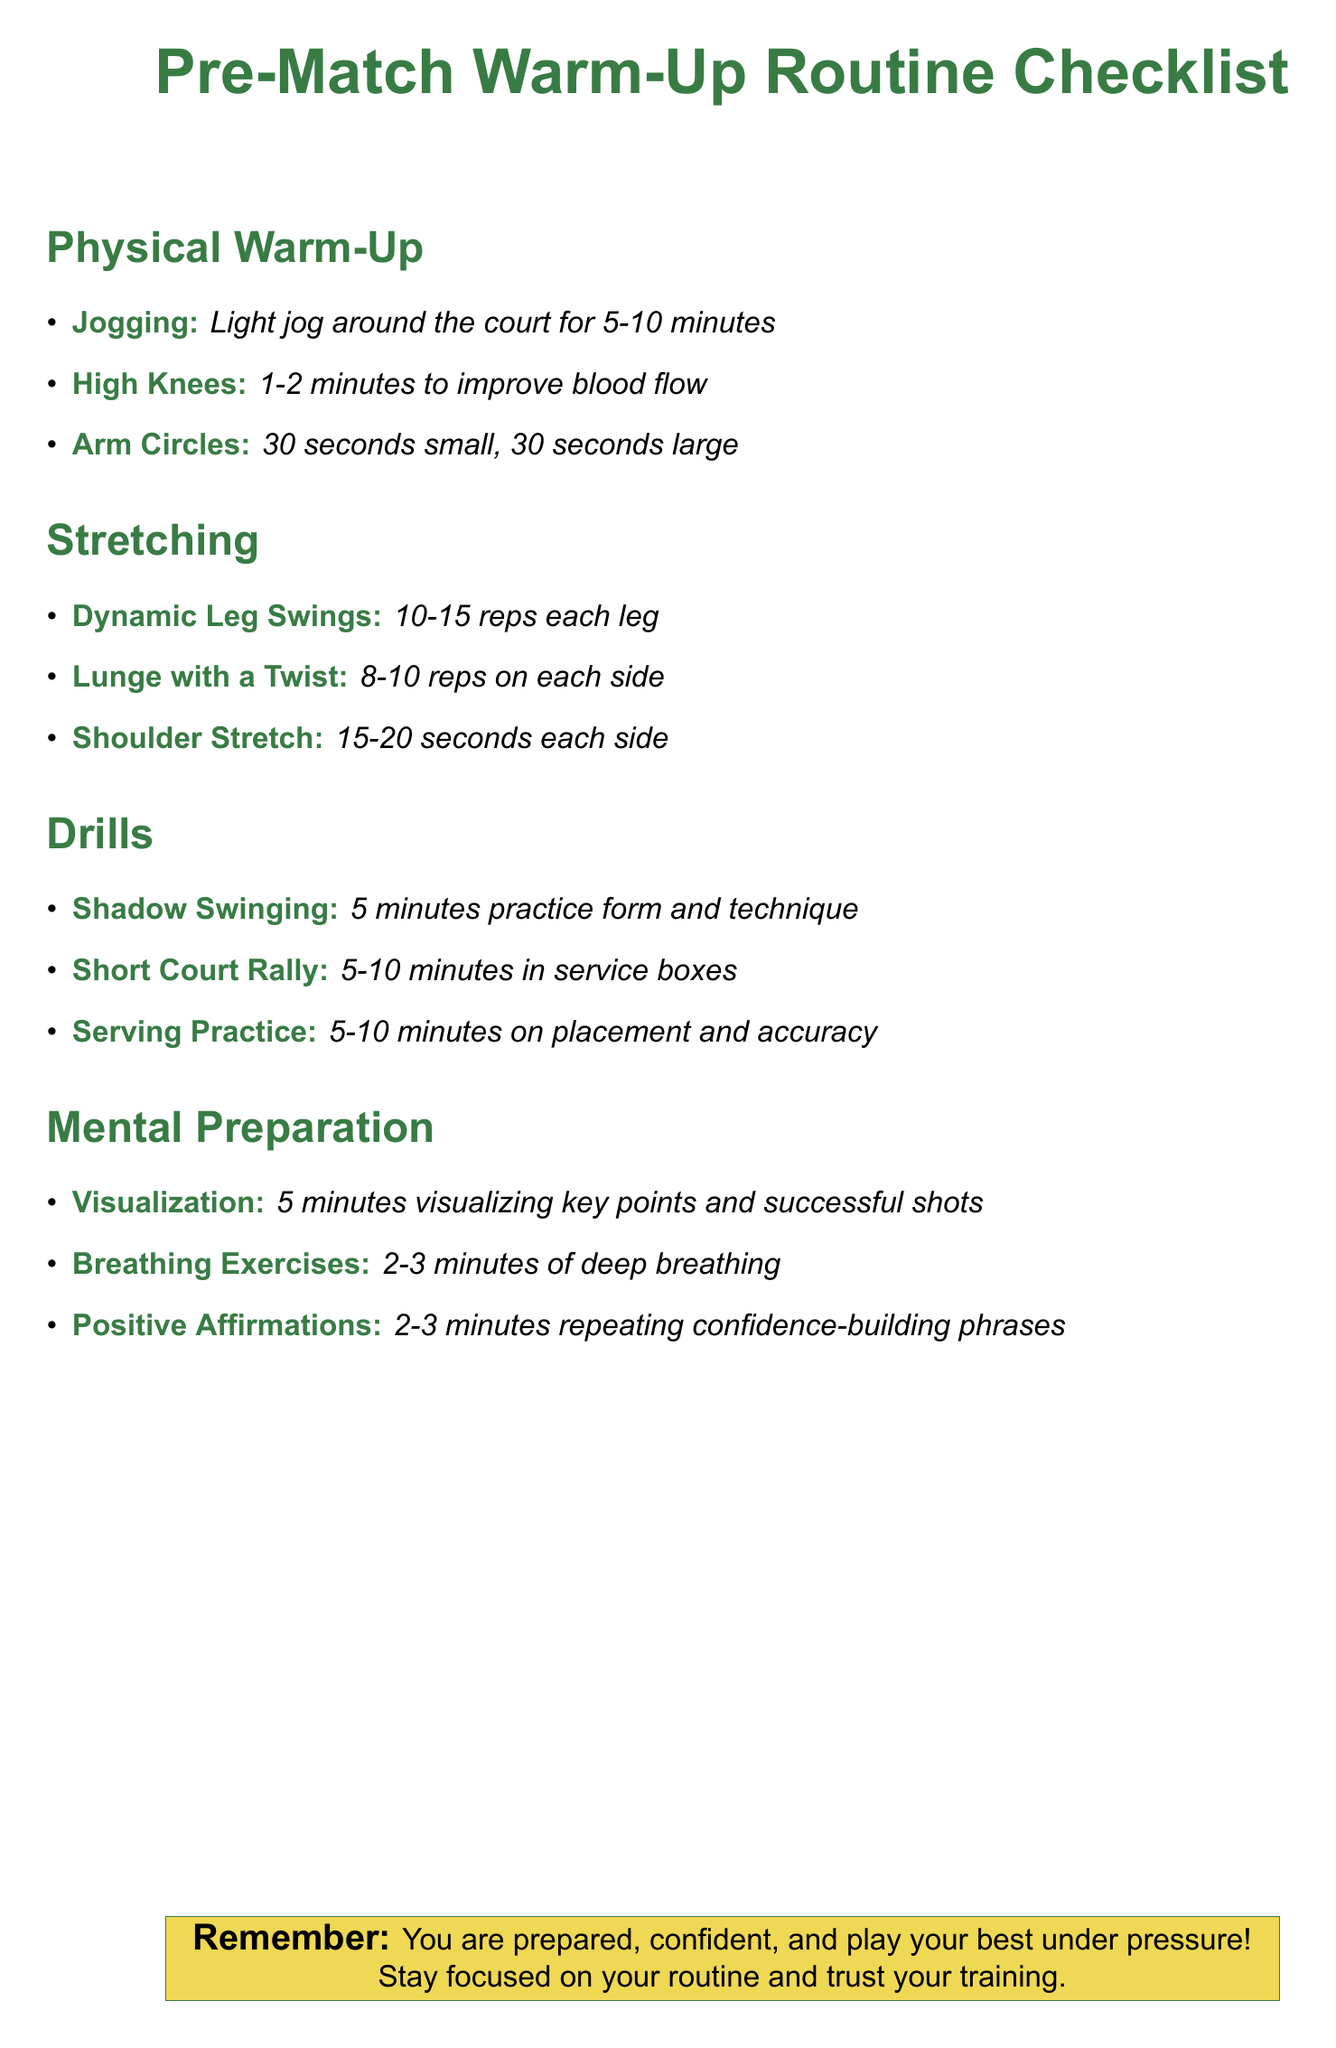What is the first exercise listed under Physical Warm-Up? The first exercise listed under Physical Warm-Up is jogging, specifically a light jog around the court for 5-10 minutes.
Answer: Jogging How long should the High Knees exercise be performed? The High Knees exercise should be performed for 1-2 minutes to improve blood flow.
Answer: 1-2 minutes How many reps of the Dynamic Leg Swings should be done for each leg? The Dynamic Leg Swings should be done for 10-15 reps for each leg.
Answer: 10-15 reps What mental preparation technique involves visualizing successful shots? The mental preparation technique that involves visualizing successful shots is visualization, which takes about 5 minutes.
Answer: Visualization How many minutes should be spent on Serving Practice? Serving Practice should take 5-10 minutes focusing on placement and accuracy.
Answer: 5-10 minutes What is included in Positive Affirmations? Positive Affirmations include repeating confidence-building phrases for 2-3 minutes.
Answer: Repeating confidence-building phrases What is the total time suggested for breathing exercises? The suggested total time for breathing exercises is 2-3 minutes of deep breathing.
Answer: 2-3 minutes How long is the recommended time for Shadow Swinging? Shadow Swinging is recommended for 5 minutes to practice form and technique.
Answer: 5 minutes 